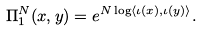Convert formula to latex. <formula><loc_0><loc_0><loc_500><loc_500>\Pi _ { 1 } ^ { N } ( x , y ) = e ^ { N \log \langle \iota ( x ) , \iota ( y ) \rangle } .</formula> 